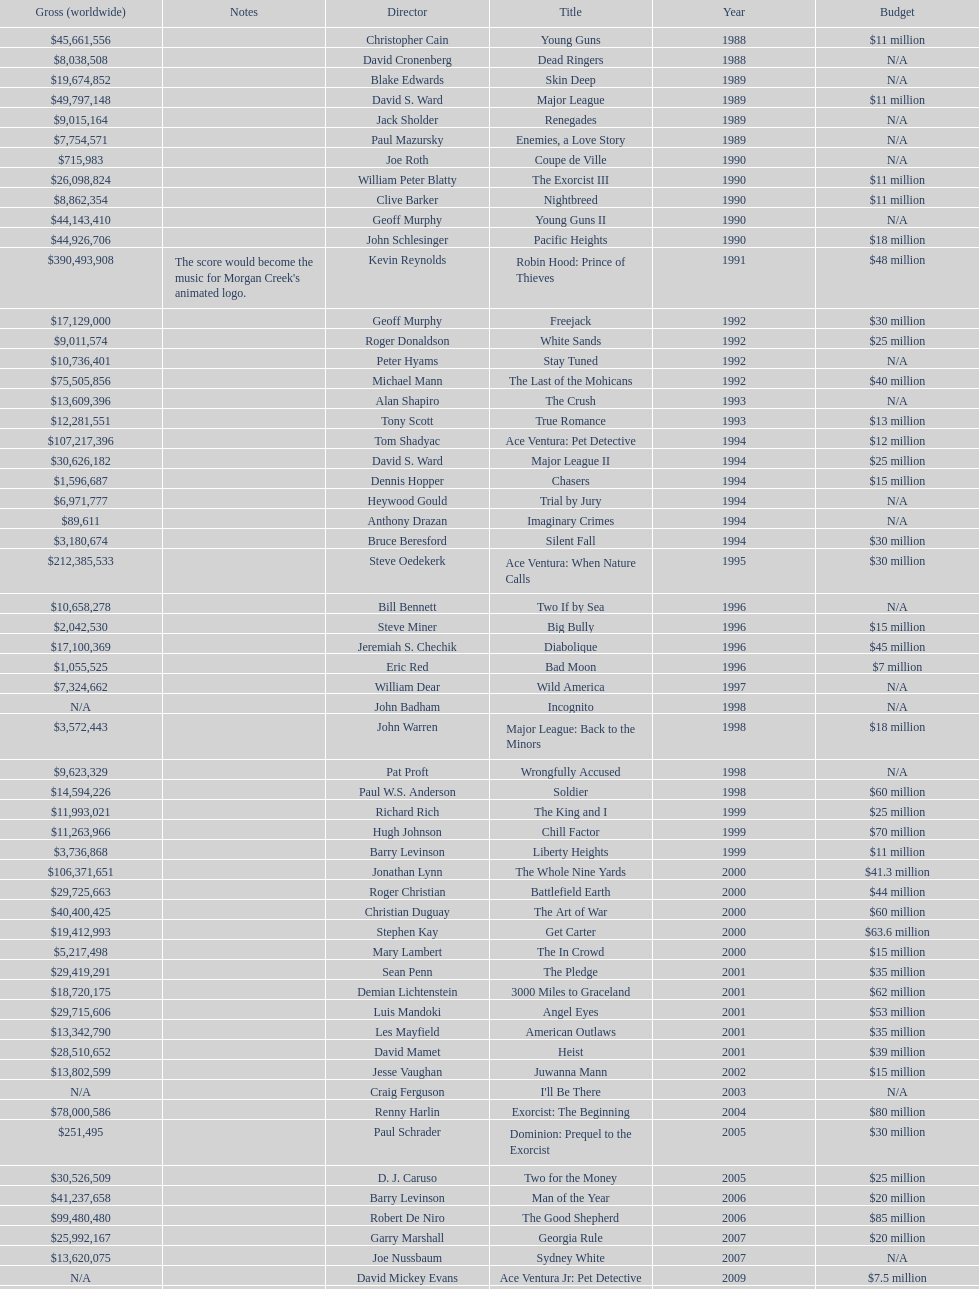Was the budget for young guns more or less than freejack's budget? Less. 